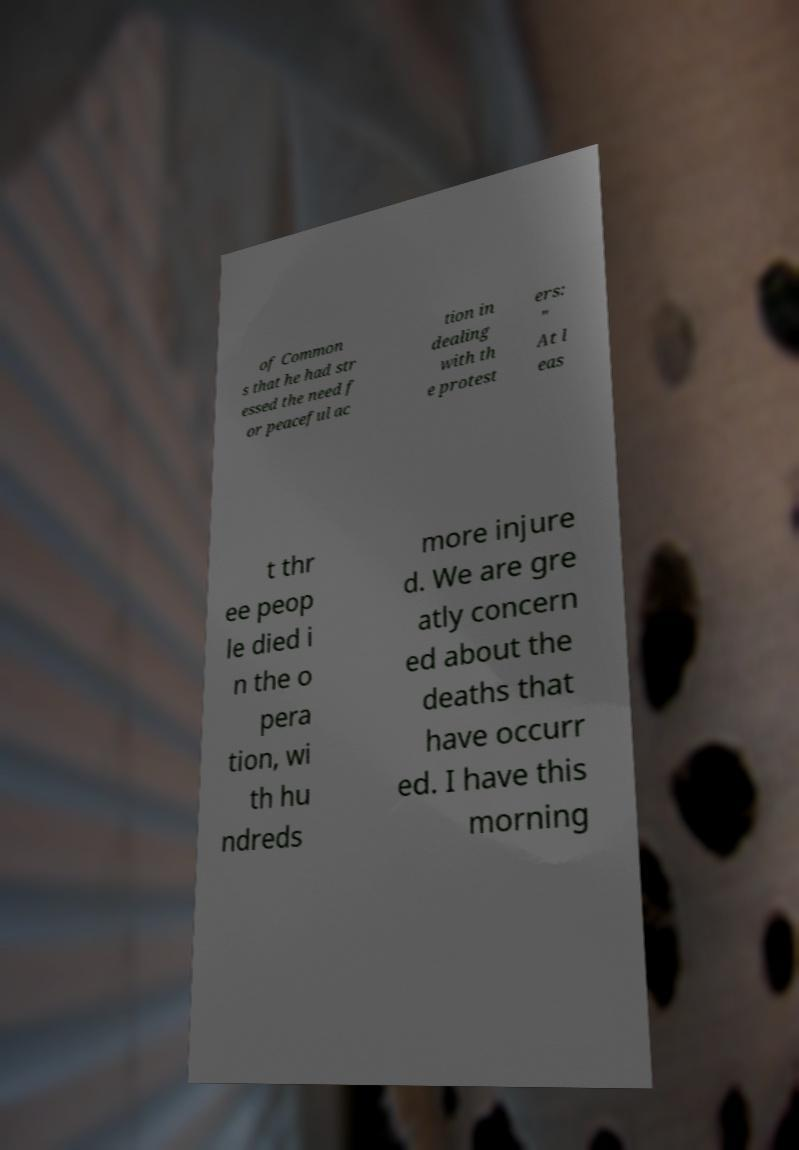Can you read and provide the text displayed in the image?This photo seems to have some interesting text. Can you extract and type it out for me? of Common s that he had str essed the need f or peaceful ac tion in dealing with th e protest ers: " At l eas t thr ee peop le died i n the o pera tion, wi th hu ndreds more injure d. We are gre atly concern ed about the deaths that have occurr ed. I have this morning 